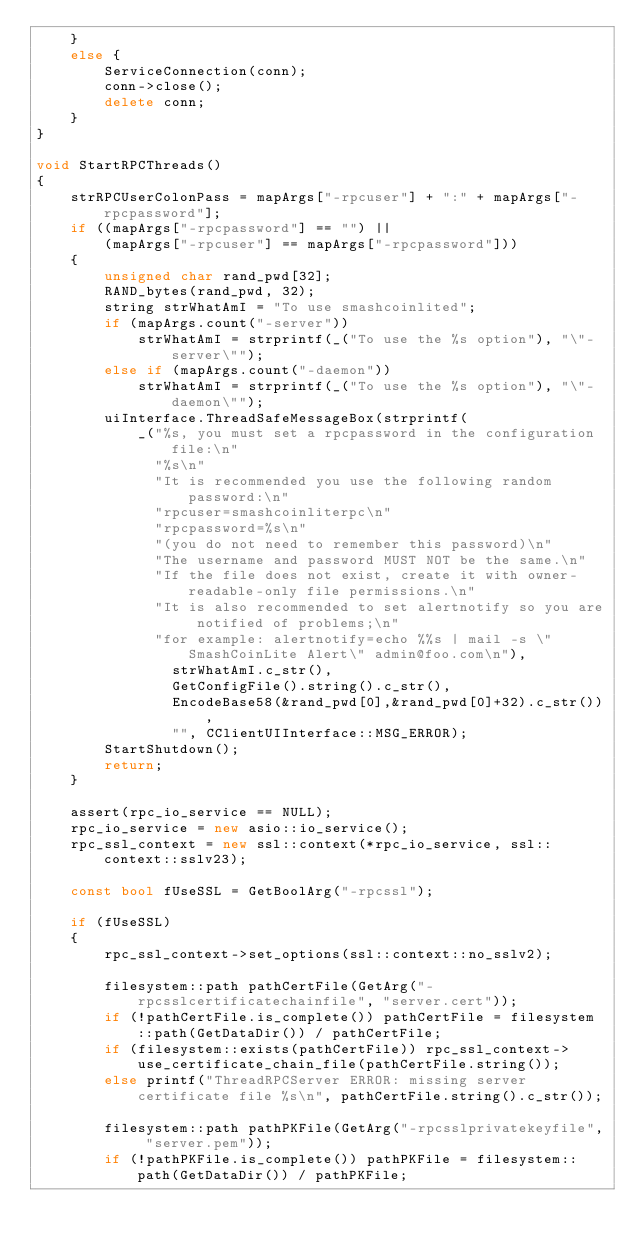<code> <loc_0><loc_0><loc_500><loc_500><_C++_>    }
    else {
        ServiceConnection(conn);
        conn->close();
        delete conn;
    }
}

void StartRPCThreads()
{
    strRPCUserColonPass = mapArgs["-rpcuser"] + ":" + mapArgs["-rpcpassword"];
    if ((mapArgs["-rpcpassword"] == "") ||
        (mapArgs["-rpcuser"] == mapArgs["-rpcpassword"]))
    {
        unsigned char rand_pwd[32];
        RAND_bytes(rand_pwd, 32);
        string strWhatAmI = "To use smashcoinlited";
        if (mapArgs.count("-server"))
            strWhatAmI = strprintf(_("To use the %s option"), "\"-server\"");
        else if (mapArgs.count("-daemon"))
            strWhatAmI = strprintf(_("To use the %s option"), "\"-daemon\"");
        uiInterface.ThreadSafeMessageBox(strprintf(
            _("%s, you must set a rpcpassword in the configuration file:\n"
              "%s\n"
              "It is recommended you use the following random password:\n"
              "rpcuser=smashcoinliterpc\n"
              "rpcpassword=%s\n"
              "(you do not need to remember this password)\n"
              "The username and password MUST NOT be the same.\n"
              "If the file does not exist, create it with owner-readable-only file permissions.\n"
              "It is also recommended to set alertnotify so you are notified of problems;\n"
              "for example: alertnotify=echo %%s | mail -s \"SmashCoinLite Alert\" admin@foo.com\n"),
                strWhatAmI.c_str(),
                GetConfigFile().string().c_str(),
                EncodeBase58(&rand_pwd[0],&rand_pwd[0]+32).c_str()),
                "", CClientUIInterface::MSG_ERROR);
        StartShutdown();
        return;
    }

    assert(rpc_io_service == NULL);
    rpc_io_service = new asio::io_service();
    rpc_ssl_context = new ssl::context(*rpc_io_service, ssl::context::sslv23);

    const bool fUseSSL = GetBoolArg("-rpcssl");

    if (fUseSSL)
    {
        rpc_ssl_context->set_options(ssl::context::no_sslv2);

        filesystem::path pathCertFile(GetArg("-rpcsslcertificatechainfile", "server.cert"));
        if (!pathCertFile.is_complete()) pathCertFile = filesystem::path(GetDataDir()) / pathCertFile;
        if (filesystem::exists(pathCertFile)) rpc_ssl_context->use_certificate_chain_file(pathCertFile.string());
        else printf("ThreadRPCServer ERROR: missing server certificate file %s\n", pathCertFile.string().c_str());

        filesystem::path pathPKFile(GetArg("-rpcsslprivatekeyfile", "server.pem"));
        if (!pathPKFile.is_complete()) pathPKFile = filesystem::path(GetDataDir()) / pathPKFile;</code> 